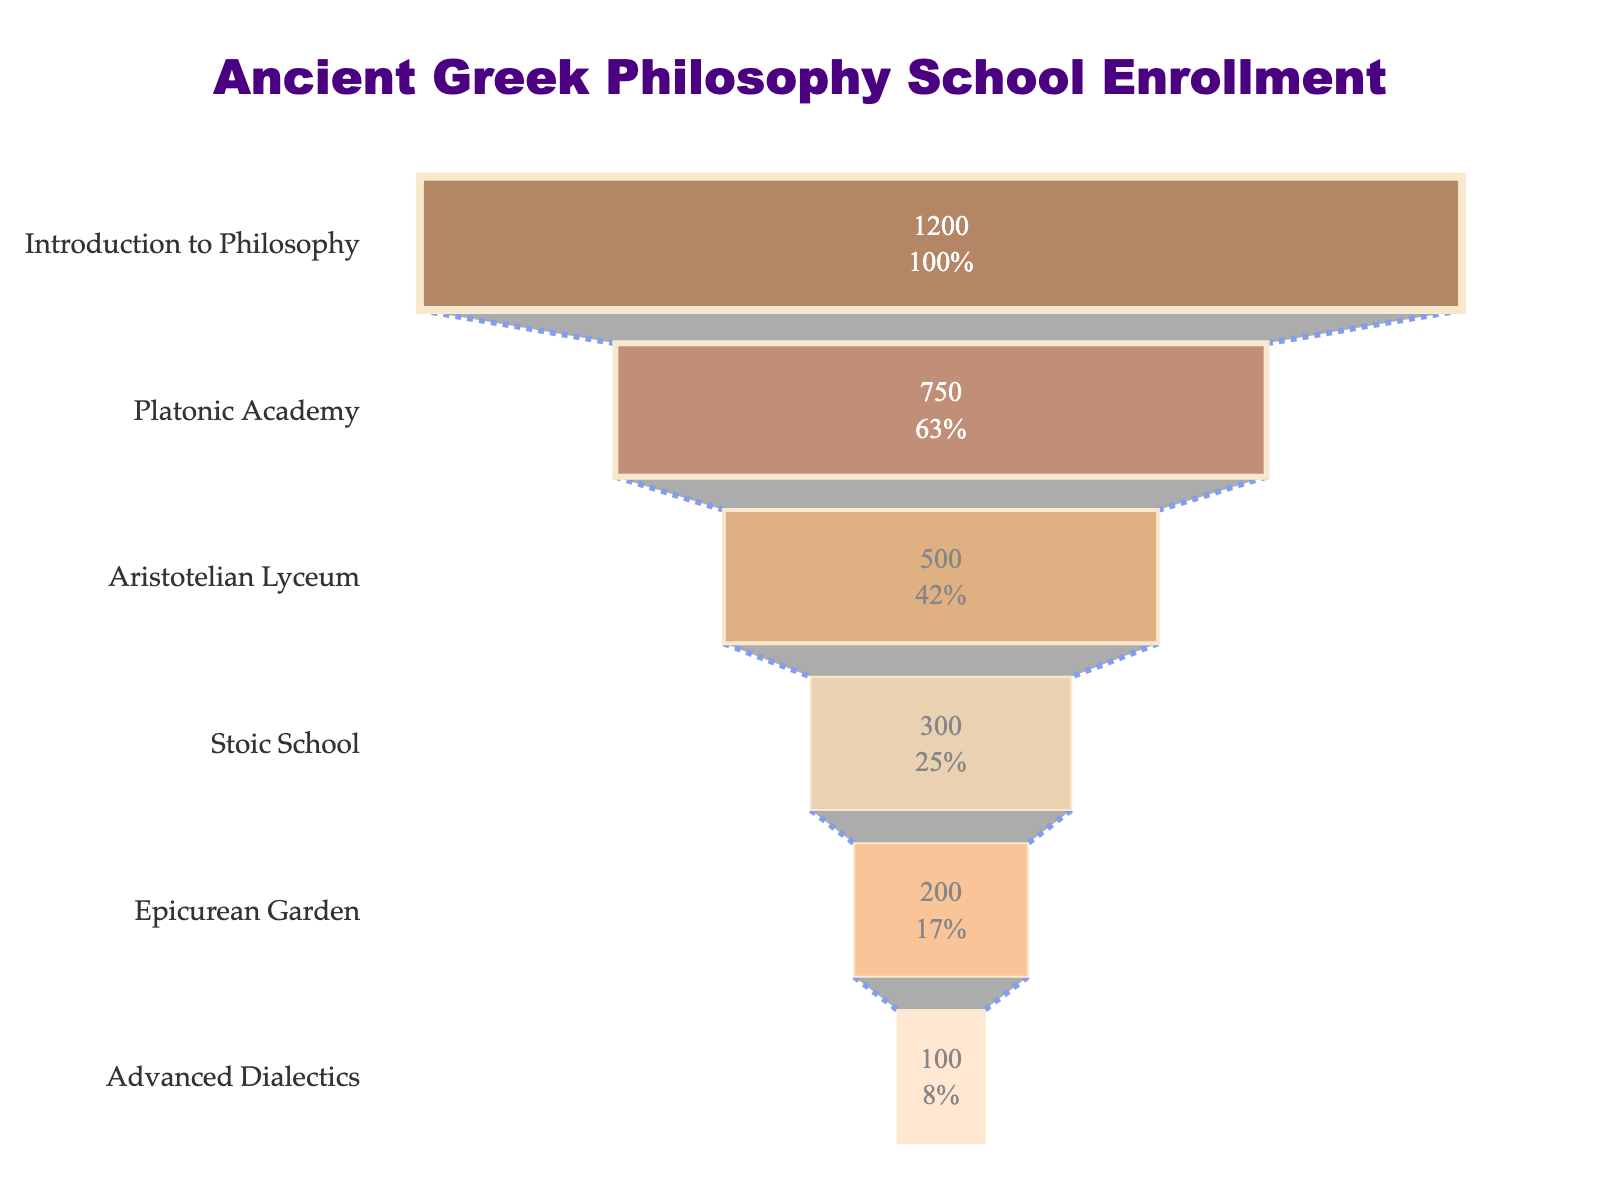What is the title of the funnel chart? The title of the chart is displayed prominently at the top of the figure in a larger and bold font. It reads "Ancient Greek Philosophy School Enrollment".
Answer: Ancient Greek Philosophy School Enrollment How many levels of study are depicted in the funnel chart? The funnel chart has distinct segments, each representing a different level of study. By counting these segments, we can see that there are 6 levels of study illustrated.
Answer: 6 Which level of study has the highest number of students? The highest number of students is represented by the widest part of the funnel chart, which is at the bottom. The "Introduction to Philosophy" level has 1200 students, the largest number among all levels.
Answer: Introduction to Philosophy What percentage of students remain after the Stoic School level? The "Stoic School" level shows the number of students and the percentage of the initial number remaining. There are 300 students remaining, which is 25% of the initial 1200 students.
Answer: 25% What is the sum of students in the Aristotelian Lyceum and Epicurean Garden levels? The number of students in the Aristotelian Lyceum level is 500, and in the Epicurean Garden level, there are 200 students. Adding these together gives 500 + 200 = 700.
Answer: 700 How many more students are there in the Platonic Academy level than in the Advanced Dialectics level? The Platonic Academy level has 750 students, while the Advanced Dialectics level has 100 students. The difference between them is 750 - 100 = 650.
Answer: 650 How does the enrollment in the Stoic School compare to the Epicurean Garden? The Stoic School has 300 students and the Epicurean Garden has 200 students. Comparatively, the Stoic School has more students by a difference of 300 - 200 = 100.
Answer: 100 more At what level does the number of students first fall below 500? Starting from the top and moving down, the first level where the number of students falls below 500 is the "Aristotelian Lyceum", which has exactly 500 students.
Answer: Aristotelian Lyceum What fraction of students who started in Introduction to Philosophy end up in Advanced Dialectics? The Introduction to Philosophy level starts with 1200 students, and the Advanced Dialectics level ends with 100 students. The fraction is calculated as 100/1200, which simplifies to 1/12.
Answer: 1/12 Which school shows the second largest drop in the number of students? Looking at the differences between consecutive levels, the largest drop is from Introduction to Philosophy to Platonic Academy (450 students), and the second largest drop is from Platonic Academy to Aristotelian Lyceum (250 students).
Answer: Platonic Academy to Aristotelian Lyceum 